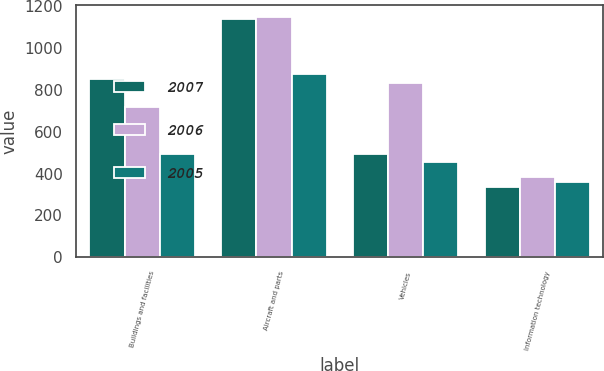Convert chart. <chart><loc_0><loc_0><loc_500><loc_500><stacked_bar_chart><ecel><fcel>Buildings and facilities<fcel>Aircraft and parts<fcel>Vehicles<fcel>Information technology<nl><fcel>2007<fcel>853<fcel>1137<fcel>492<fcel>338<nl><fcel>2006<fcel>720<fcel>1150<fcel>831<fcel>384<nl><fcel>2005<fcel>495<fcel>874<fcel>456<fcel>362<nl></chart> 